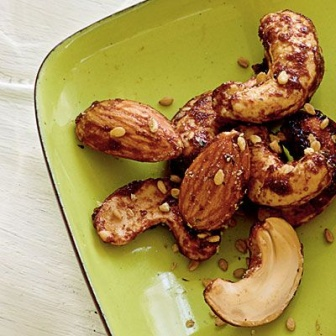Can you create a descriptive poem about the scene? Upon a plate of verdant hue,
A cluster of roasted nuts we view.
Cashews golden, shining bright,
Almonds dark, a roasted delight.
Sprinkled seeds of sesharegpt4v/same light,
Enhancing flavors, a gentle bite.
On white wood they rest in grace,
A rustic charm, a peaceful place.
Simple joys in a vibrant array,
A perfect treat to start the day. 